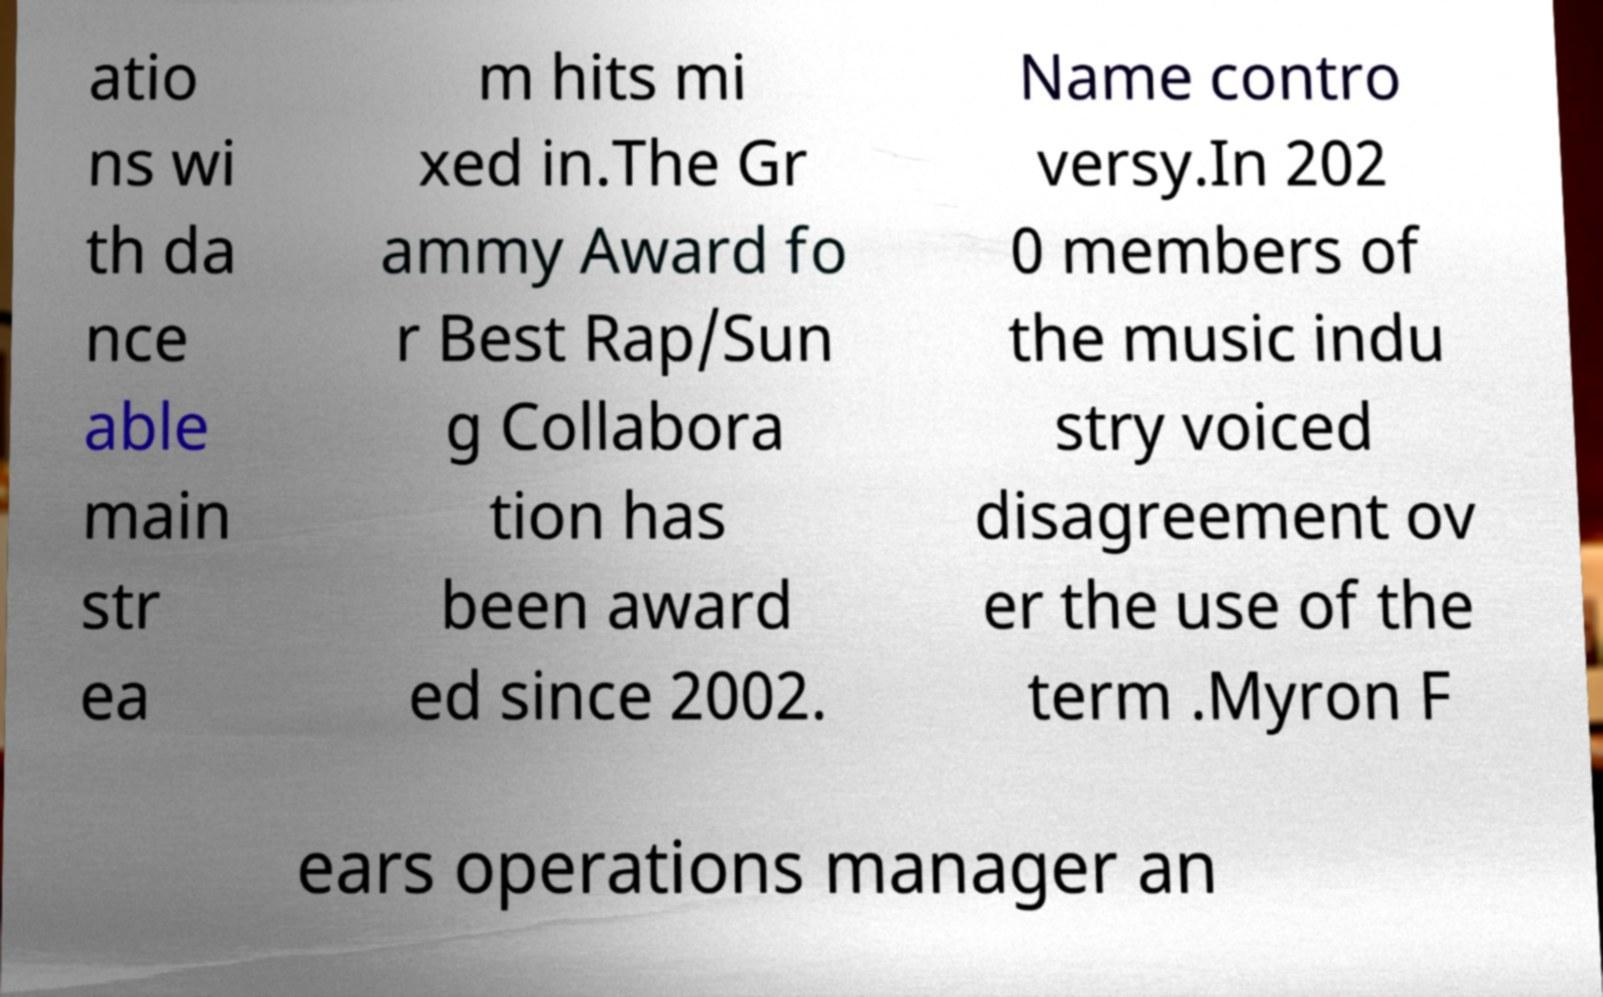Can you accurately transcribe the text from the provided image for me? atio ns wi th da nce able main str ea m hits mi xed in.The Gr ammy Award fo r Best Rap/Sun g Collabora tion has been award ed since 2002. Name contro versy.In 202 0 members of the music indu stry voiced disagreement ov er the use of the term .Myron F ears operations manager an 